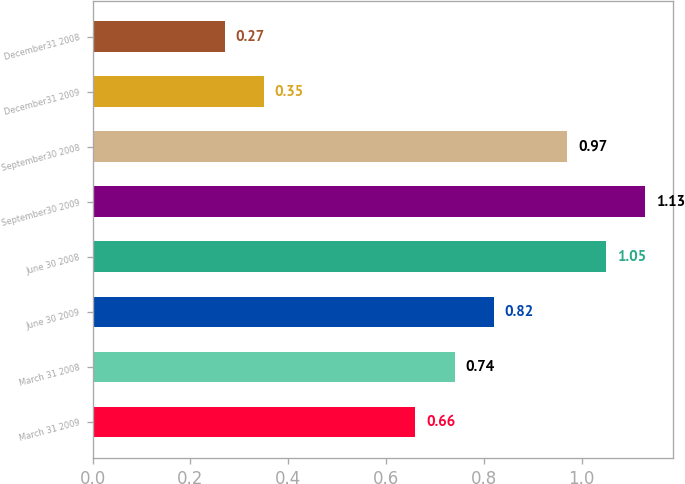Convert chart to OTSL. <chart><loc_0><loc_0><loc_500><loc_500><bar_chart><fcel>March 31 2009<fcel>March 31 2008<fcel>June 30 2009<fcel>June 30 2008<fcel>September30 2009<fcel>September30 2008<fcel>December31 2009<fcel>December31 2008<nl><fcel>0.66<fcel>0.74<fcel>0.82<fcel>1.05<fcel>1.13<fcel>0.97<fcel>0.35<fcel>0.27<nl></chart> 